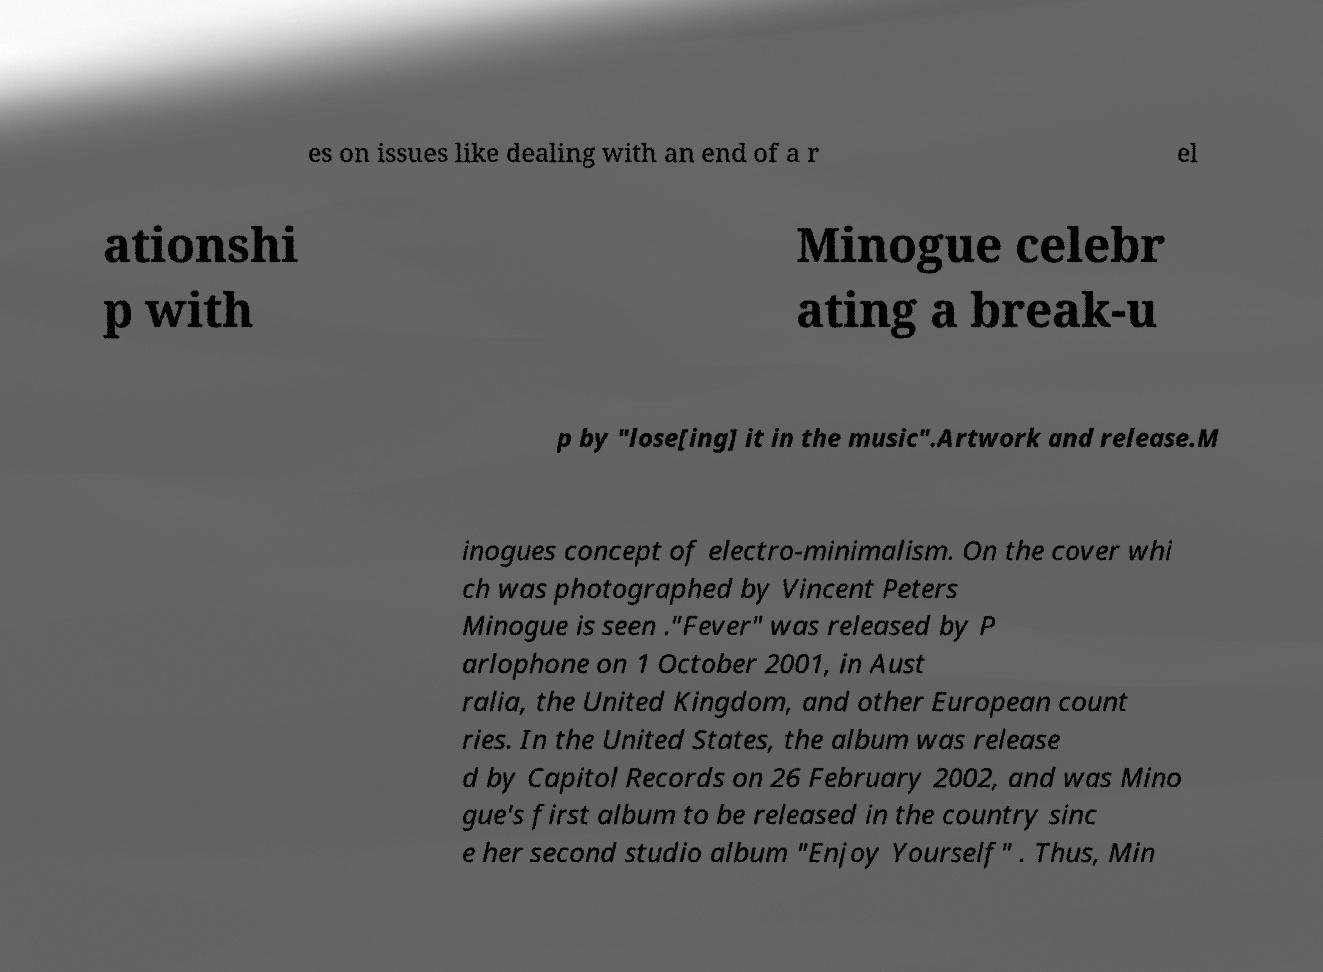For documentation purposes, I need the text within this image transcribed. Could you provide that? es on issues like dealing with an end of a r el ationshi p with Minogue celebr ating a break-u p by "lose[ing] it in the music".Artwork and release.M inogues concept of electro-minimalism. On the cover whi ch was photographed by Vincent Peters Minogue is seen ."Fever" was released by P arlophone on 1 October 2001, in Aust ralia, the United Kingdom, and other European count ries. In the United States, the album was release d by Capitol Records on 26 February 2002, and was Mino gue's first album to be released in the country sinc e her second studio album "Enjoy Yourself" . Thus, Min 